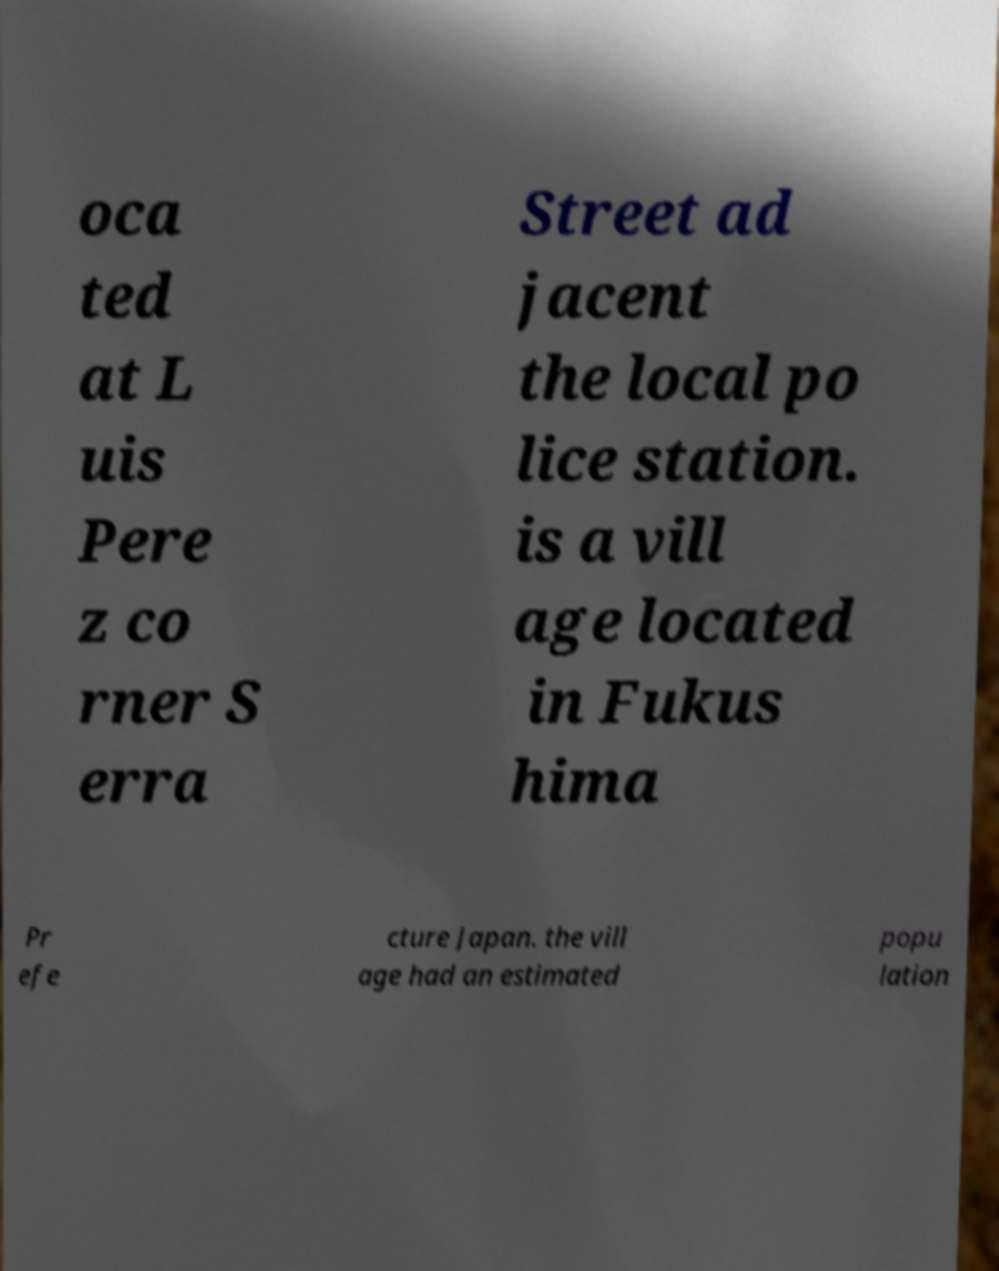Can you accurately transcribe the text from the provided image for me? oca ted at L uis Pere z co rner S erra Street ad jacent the local po lice station. is a vill age located in Fukus hima Pr efe cture Japan. the vill age had an estimated popu lation 